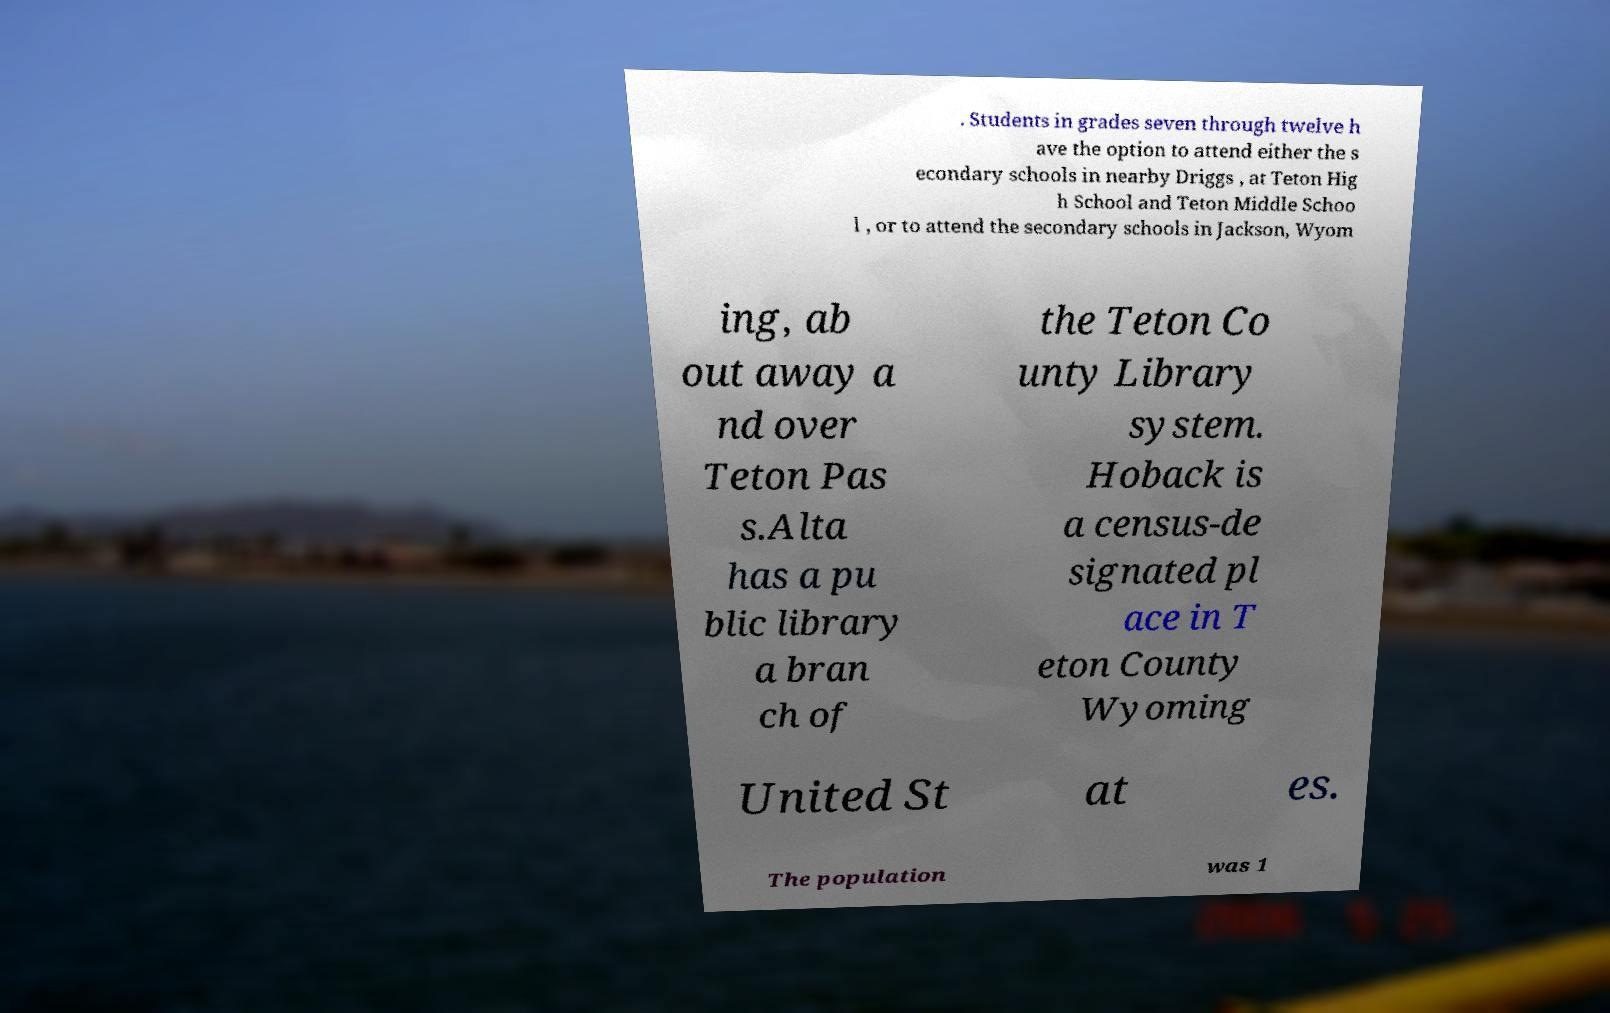Could you assist in decoding the text presented in this image and type it out clearly? . Students in grades seven through twelve h ave the option to attend either the s econdary schools in nearby Driggs , at Teton Hig h School and Teton Middle Schoo l , or to attend the secondary schools in Jackson, Wyom ing, ab out away a nd over Teton Pas s.Alta has a pu blic library a bran ch of the Teton Co unty Library system. Hoback is a census-de signated pl ace in T eton County Wyoming United St at es. The population was 1 